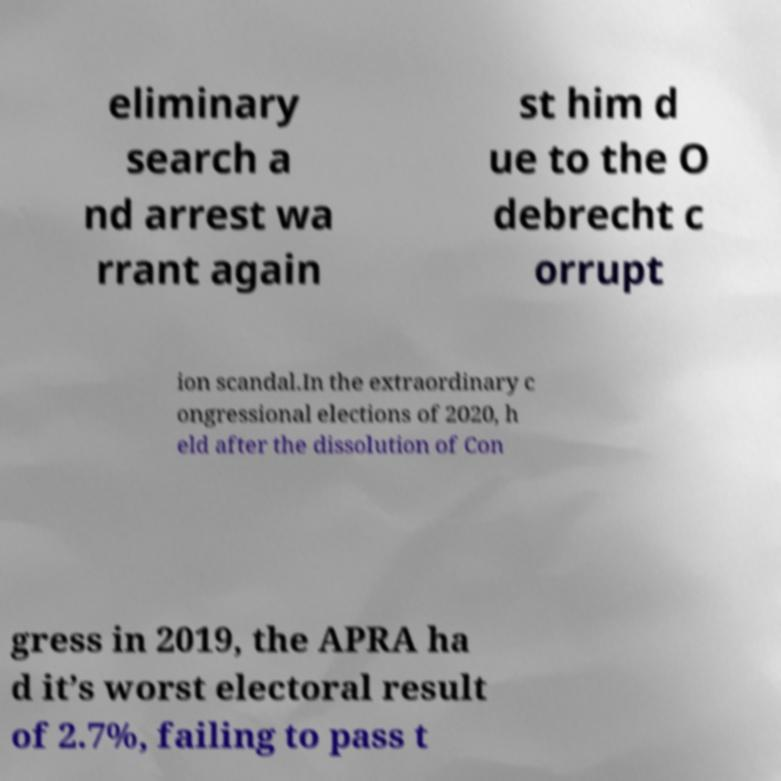Please read and relay the text visible in this image. What does it say? eliminary search a nd arrest wa rrant again st him d ue to the O debrecht c orrupt ion scandal.In the extraordinary c ongressional elections of 2020, h eld after the dissolution of Con gress in 2019, the APRA ha d it’s worst electoral result of 2.7%, failing to pass t 